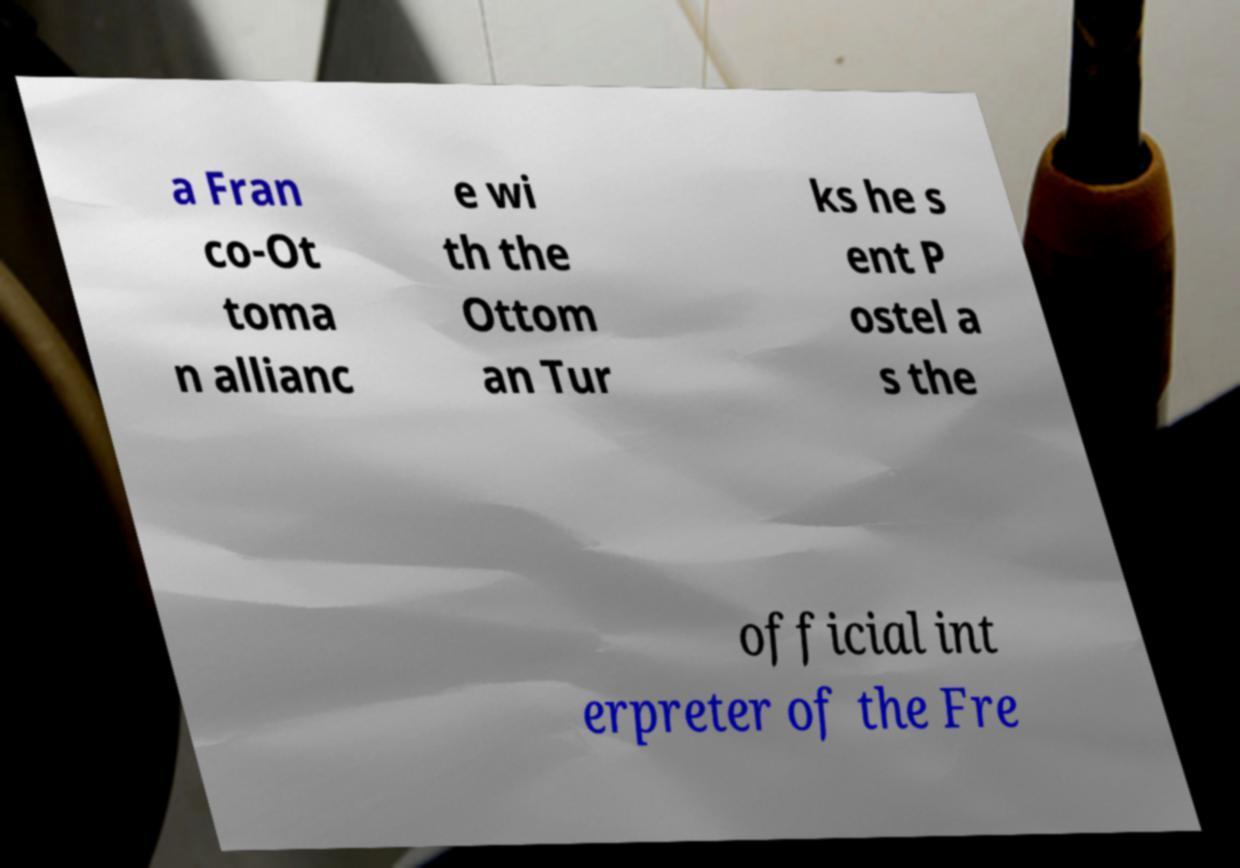Could you extract and type out the text from this image? a Fran co-Ot toma n allianc e wi th the Ottom an Tur ks he s ent P ostel a s the official int erpreter of the Fre 